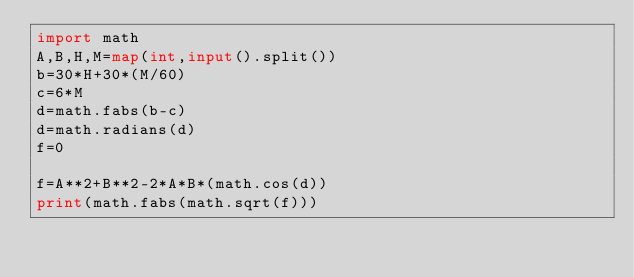<code> <loc_0><loc_0><loc_500><loc_500><_Python_>import math
A,B,H,M=map(int,input().split())
b=30*H+30*(M/60)
c=6*M
d=math.fabs(b-c)
d=math.radians(d)
f=0

f=A**2+B**2-2*A*B*(math.cos(d))
print(math.fabs(math.sqrt(f)))
</code> 